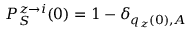<formula> <loc_0><loc_0><loc_500><loc_500>P _ { S } ^ { z \rightarrow i } ( 0 ) = 1 - \delta _ { q _ { z } ( 0 ) , A }</formula> 